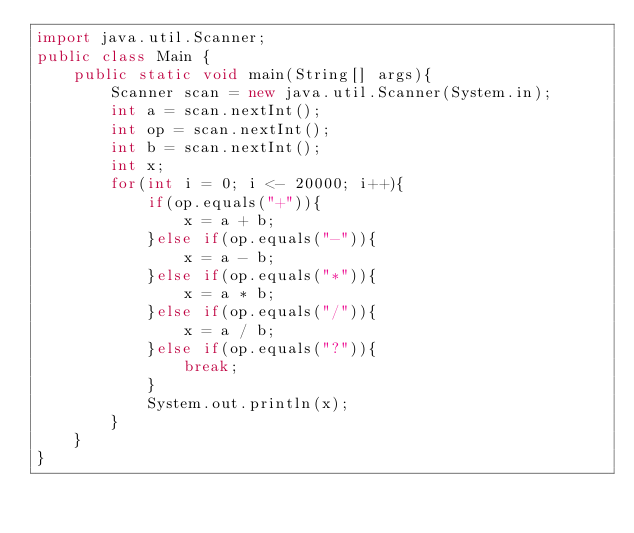<code> <loc_0><loc_0><loc_500><loc_500><_Java_>import java.util.Scanner;
public class Main {
    public static void main(String[] args){
        Scanner scan = new java.util.Scanner(System.in);
        int a = scan.nextInt();
        int op = scan.nextInt();
        int b = scan.nextInt();
        int x;
        for(int i = 0; i <- 20000; i++){
            if(op.equals("+")){
                x = a + b;
            }else if(op.equals("-")){
                x = a - b;
            }else if(op.equals("*")){
                x = a * b;
            }else if(op.equals("/")){
                x = a / b;
            }else if(op.equals("?")){
                break;
            }
            System.out.println(x);
        }
    }
}</code> 